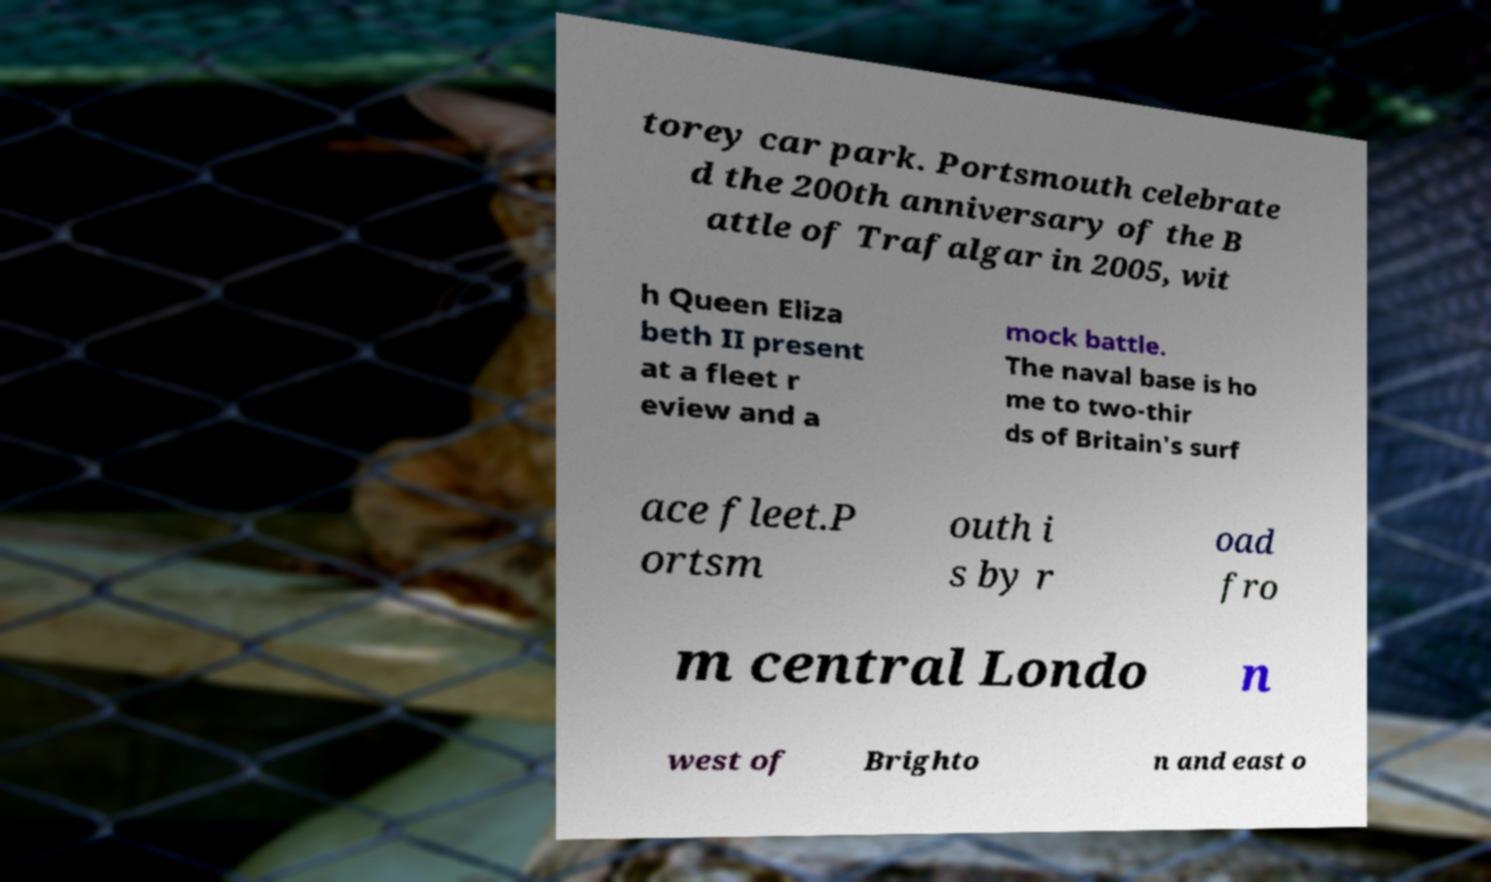There's text embedded in this image that I need extracted. Can you transcribe it verbatim? torey car park. Portsmouth celebrate d the 200th anniversary of the B attle of Trafalgar in 2005, wit h Queen Eliza beth II present at a fleet r eview and a mock battle. The naval base is ho me to two-thir ds of Britain's surf ace fleet.P ortsm outh i s by r oad fro m central Londo n west of Brighto n and east o 